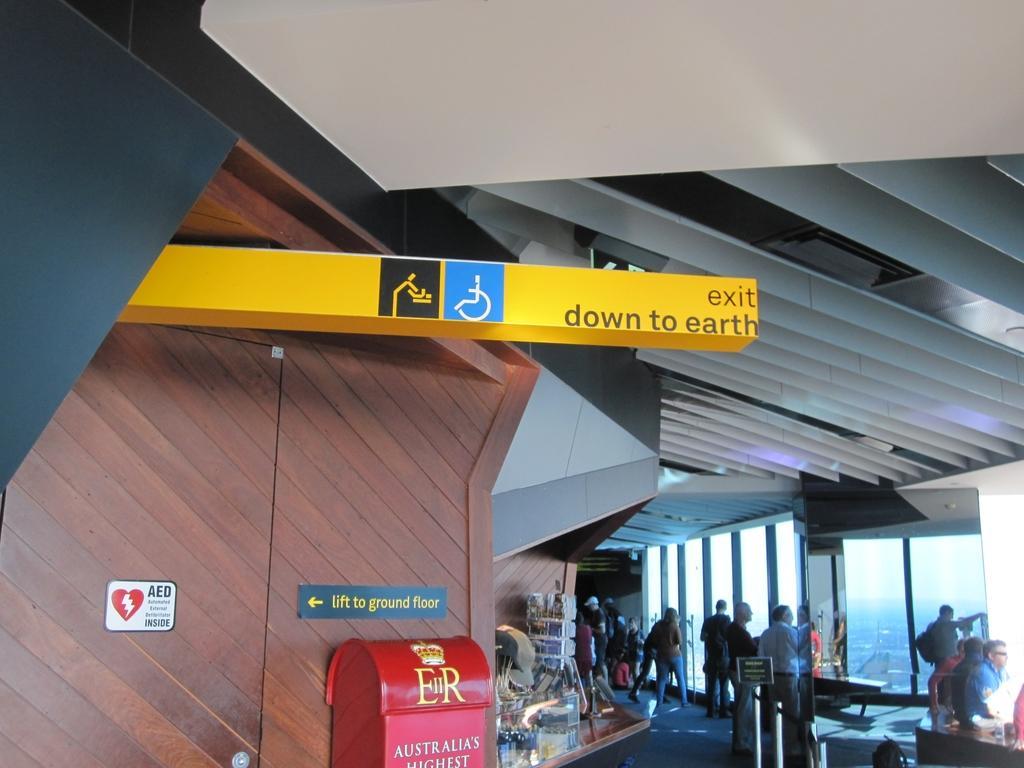Can you describe this image briefly? In this image we can see persons standing on the floor, sign boards, tables, walls and glasses. 